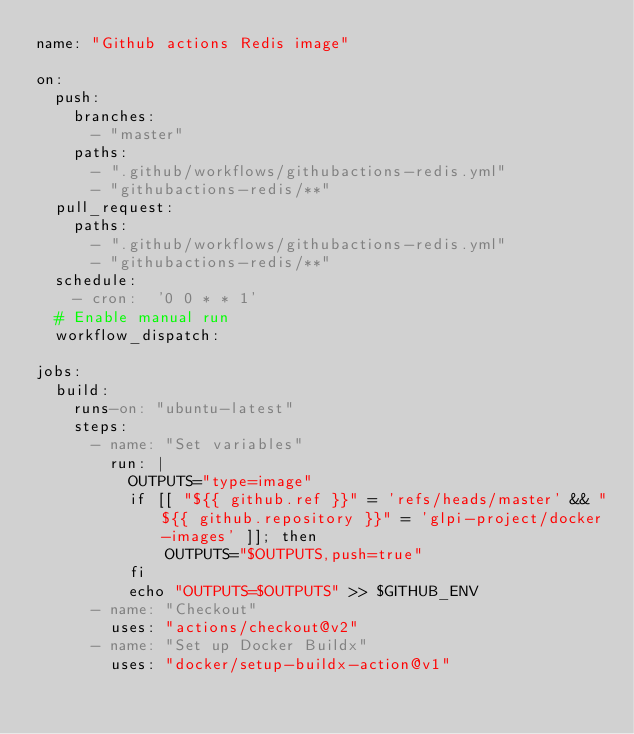<code> <loc_0><loc_0><loc_500><loc_500><_YAML_>name: "Github actions Redis image"

on:
  push:
    branches:
      - "master"
    paths:
      - ".github/workflows/githubactions-redis.yml"
      - "githubactions-redis/**"
  pull_request:
    paths:
      - ".github/workflows/githubactions-redis.yml"
      - "githubactions-redis/**"
  schedule:
    - cron:  '0 0 * * 1'
  # Enable manual run
  workflow_dispatch:

jobs:
  build:
    runs-on: "ubuntu-latest"
    steps:
      - name: "Set variables"
        run: |
          OUTPUTS="type=image"
          if [[ "${{ github.ref }}" = 'refs/heads/master' && "${{ github.repository }}" = 'glpi-project/docker-images' ]]; then
              OUTPUTS="$OUTPUTS,push=true"
          fi
          echo "OUTPUTS=$OUTPUTS" >> $GITHUB_ENV
      - name: "Checkout"
        uses: "actions/checkout@v2"
      - name: "Set up Docker Buildx"
        uses: "docker/setup-buildx-action@v1"</code> 